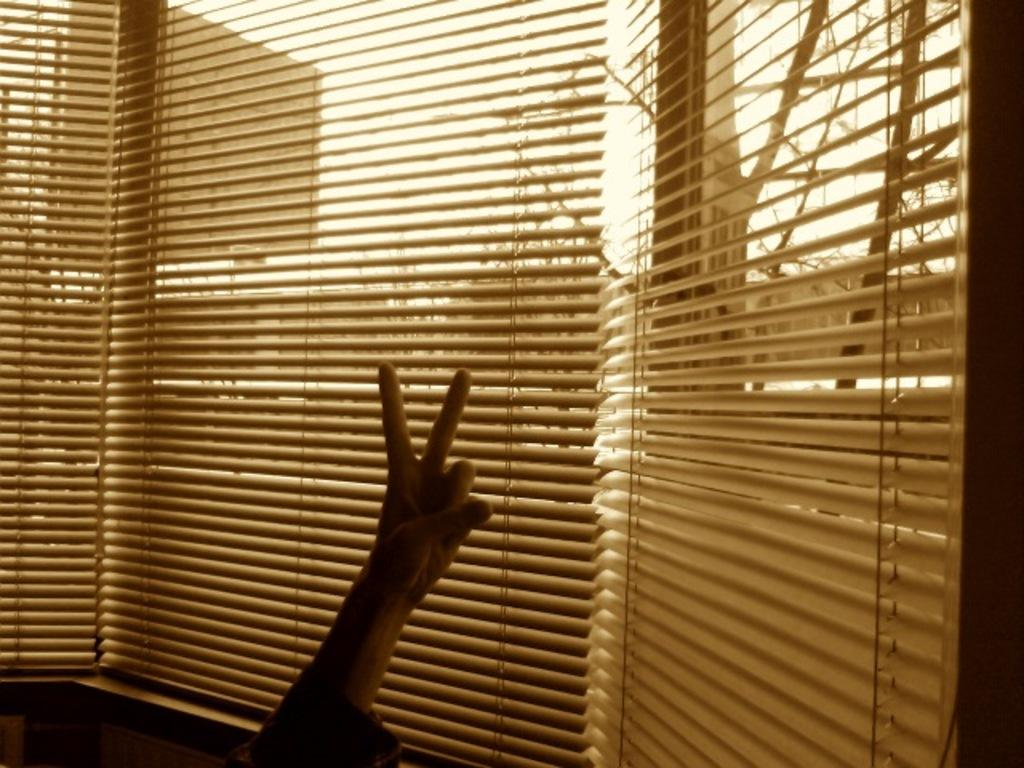What is the main subject of the picture? There is a person in the picture. What can be seen in the background of the image? There are window blinds, trees, a hoarding, and the sky visible in the background. What type of notebook is the person holding in the image? There is no notebook present in the image. Can you tell me how many uncles are visible in the image? There is no uncle present in the image. 